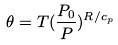Convert formula to latex. <formula><loc_0><loc_0><loc_500><loc_500>\theta = T ( \frac { P _ { 0 } } { P } ) ^ { R / c _ { p } }</formula> 